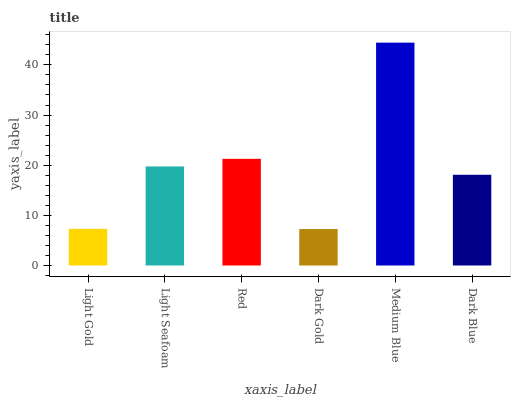Is Dark Gold the minimum?
Answer yes or no. Yes. Is Medium Blue the maximum?
Answer yes or no. Yes. Is Light Seafoam the minimum?
Answer yes or no. No. Is Light Seafoam the maximum?
Answer yes or no. No. Is Light Seafoam greater than Light Gold?
Answer yes or no. Yes. Is Light Gold less than Light Seafoam?
Answer yes or no. Yes. Is Light Gold greater than Light Seafoam?
Answer yes or no. No. Is Light Seafoam less than Light Gold?
Answer yes or no. No. Is Light Seafoam the high median?
Answer yes or no. Yes. Is Dark Blue the low median?
Answer yes or no. Yes. Is Red the high median?
Answer yes or no. No. Is Dark Gold the low median?
Answer yes or no. No. 